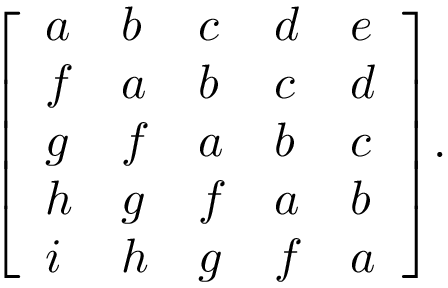<formula> <loc_0><loc_0><loc_500><loc_500>{ \left [ \begin{array} { l l l l l } { a } & { b } & { c } & { d } & { e } \\ { f } & { a } & { b } & { c } & { d } \\ { g } & { f } & { a } & { b } & { c } \\ { h } & { g } & { f } & { a } & { b } \\ { i } & { h } & { g } & { f } & { a } \end{array} \right ] } .</formula> 